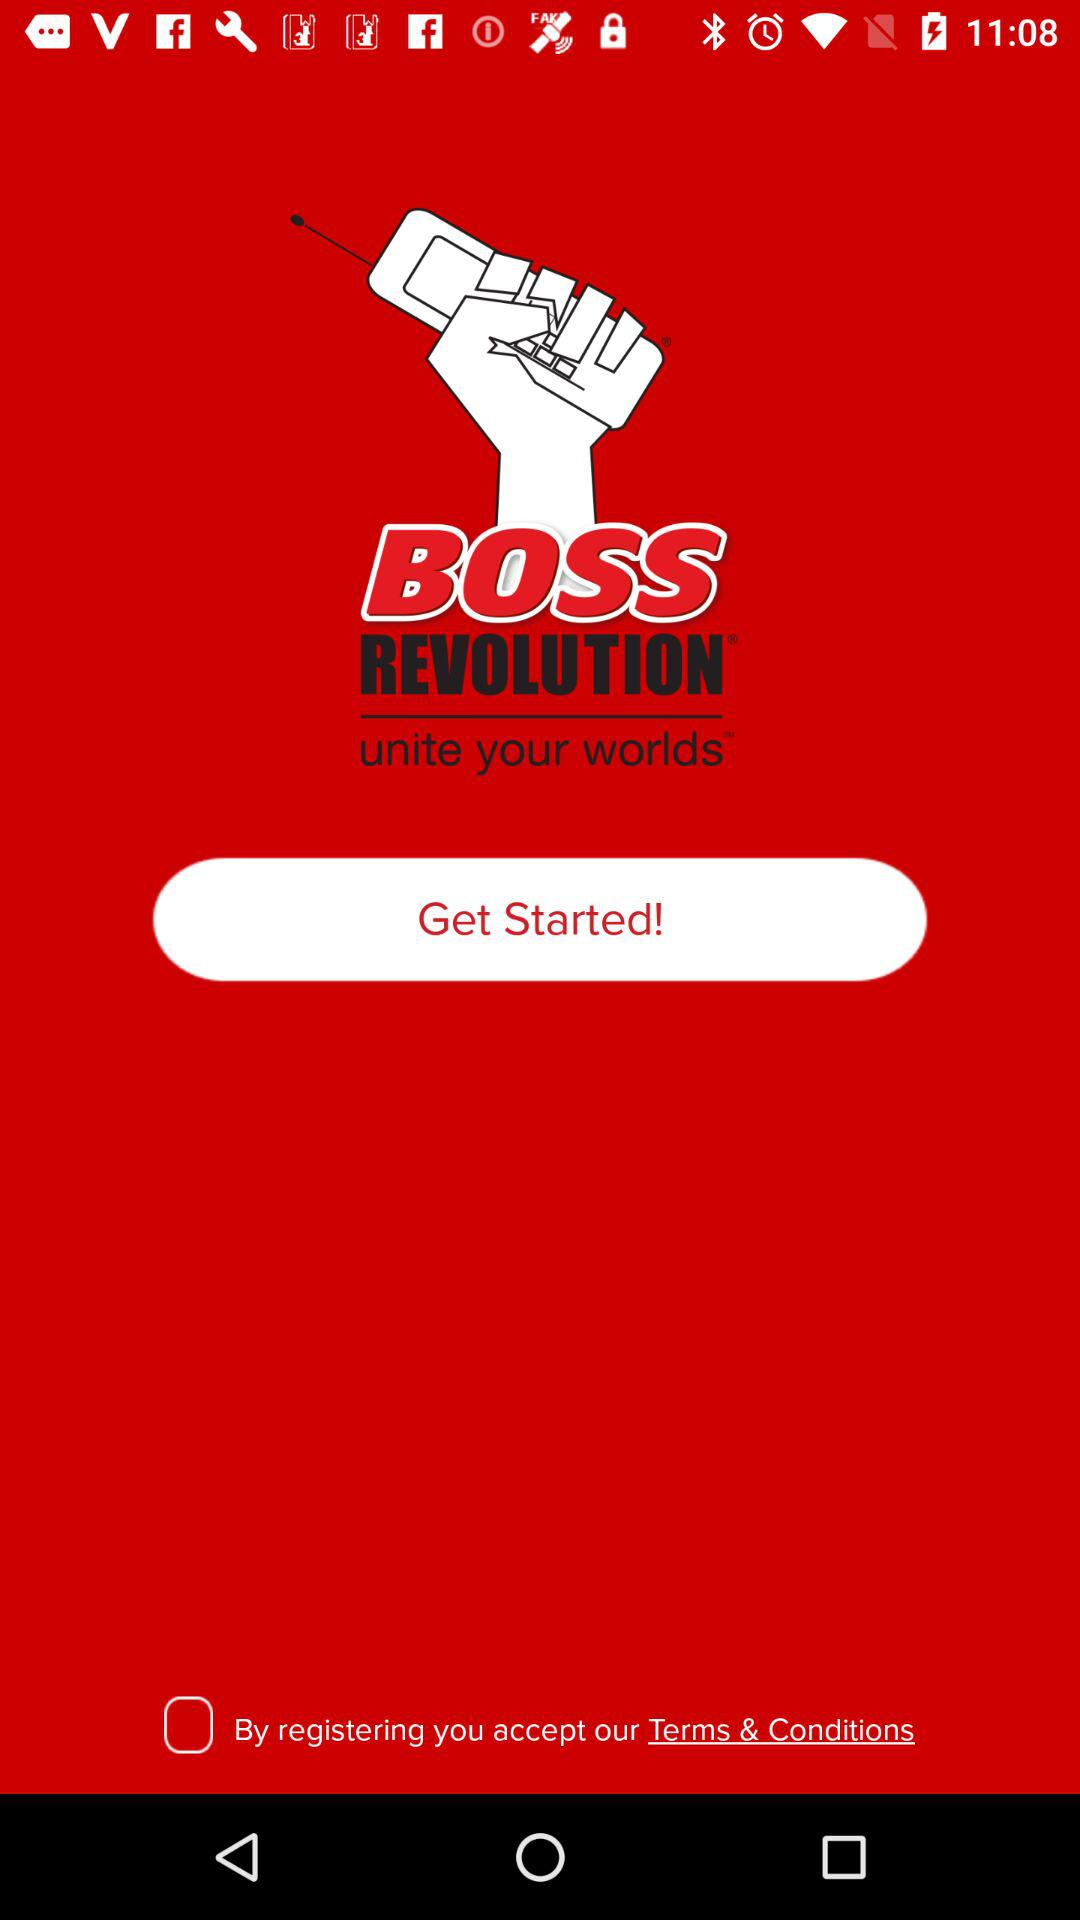What is the status of "By registering you accept our Terms and Conditions"? The status is "off". 